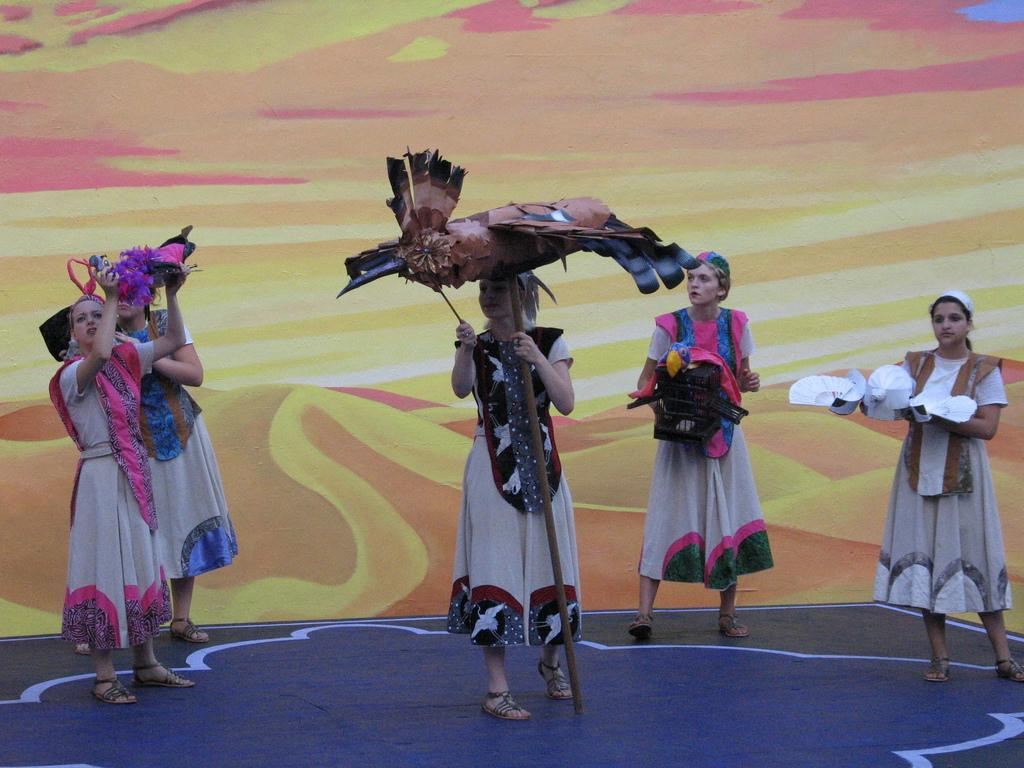What can be seen in the image? There is a group of women in the image. How are the women dressed? The women are wearing different costumes. What are the women holding in their hands? The women are holding objects in their hands. Are there any bells ringing in the image? There is no mention of bells or any sound in the image, so it cannot be determined if they are ringing. 